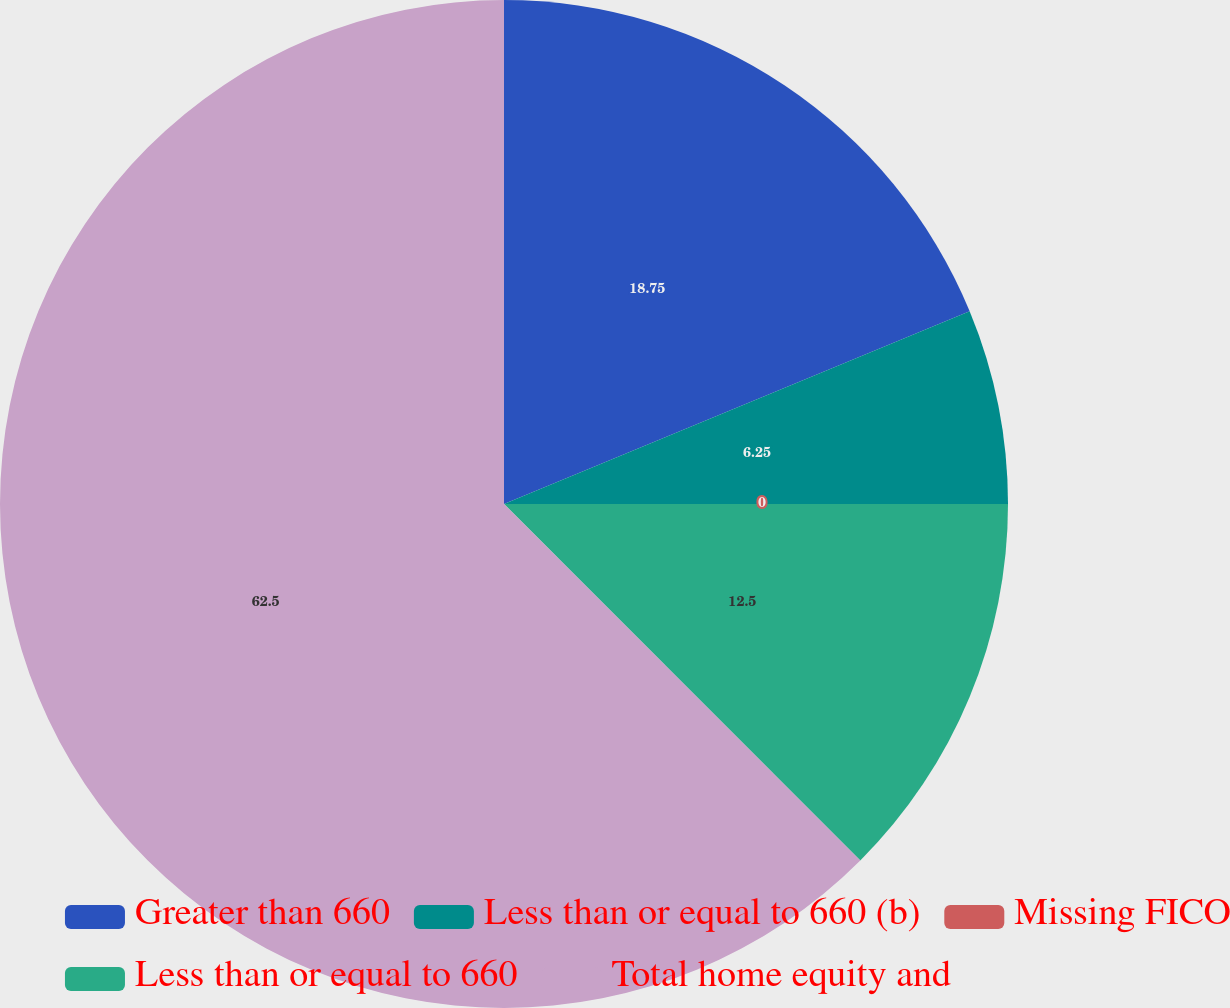Convert chart. <chart><loc_0><loc_0><loc_500><loc_500><pie_chart><fcel>Greater than 660<fcel>Less than or equal to 660 (b)<fcel>Missing FICO<fcel>Less than or equal to 660<fcel>Total home equity and<nl><fcel>18.75%<fcel>6.25%<fcel>0.0%<fcel>12.5%<fcel>62.49%<nl></chart> 